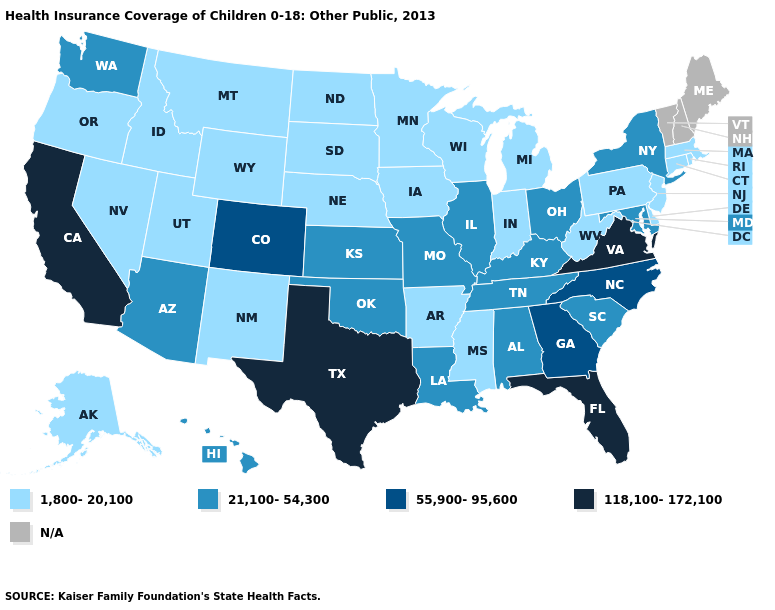Name the states that have a value in the range 55,900-95,600?
Concise answer only. Colorado, Georgia, North Carolina. What is the value of Colorado?
Concise answer only. 55,900-95,600. What is the value of Maine?
Quick response, please. N/A. Name the states that have a value in the range 21,100-54,300?
Answer briefly. Alabama, Arizona, Hawaii, Illinois, Kansas, Kentucky, Louisiana, Maryland, Missouri, New York, Ohio, Oklahoma, South Carolina, Tennessee, Washington. What is the highest value in the Northeast ?
Keep it brief. 21,100-54,300. Does Massachusetts have the lowest value in the Northeast?
Answer briefly. Yes. Does Alabama have the lowest value in the USA?
Keep it brief. No. Among the states that border Connecticut , does Rhode Island have the highest value?
Give a very brief answer. No. Name the states that have a value in the range 118,100-172,100?
Be succinct. California, Florida, Texas, Virginia. Does the first symbol in the legend represent the smallest category?
Give a very brief answer. Yes. Among the states that border Utah , does Colorado have the lowest value?
Keep it brief. No. What is the value of Alabama?
Keep it brief. 21,100-54,300. Which states have the lowest value in the West?
Quick response, please. Alaska, Idaho, Montana, Nevada, New Mexico, Oregon, Utah, Wyoming. 